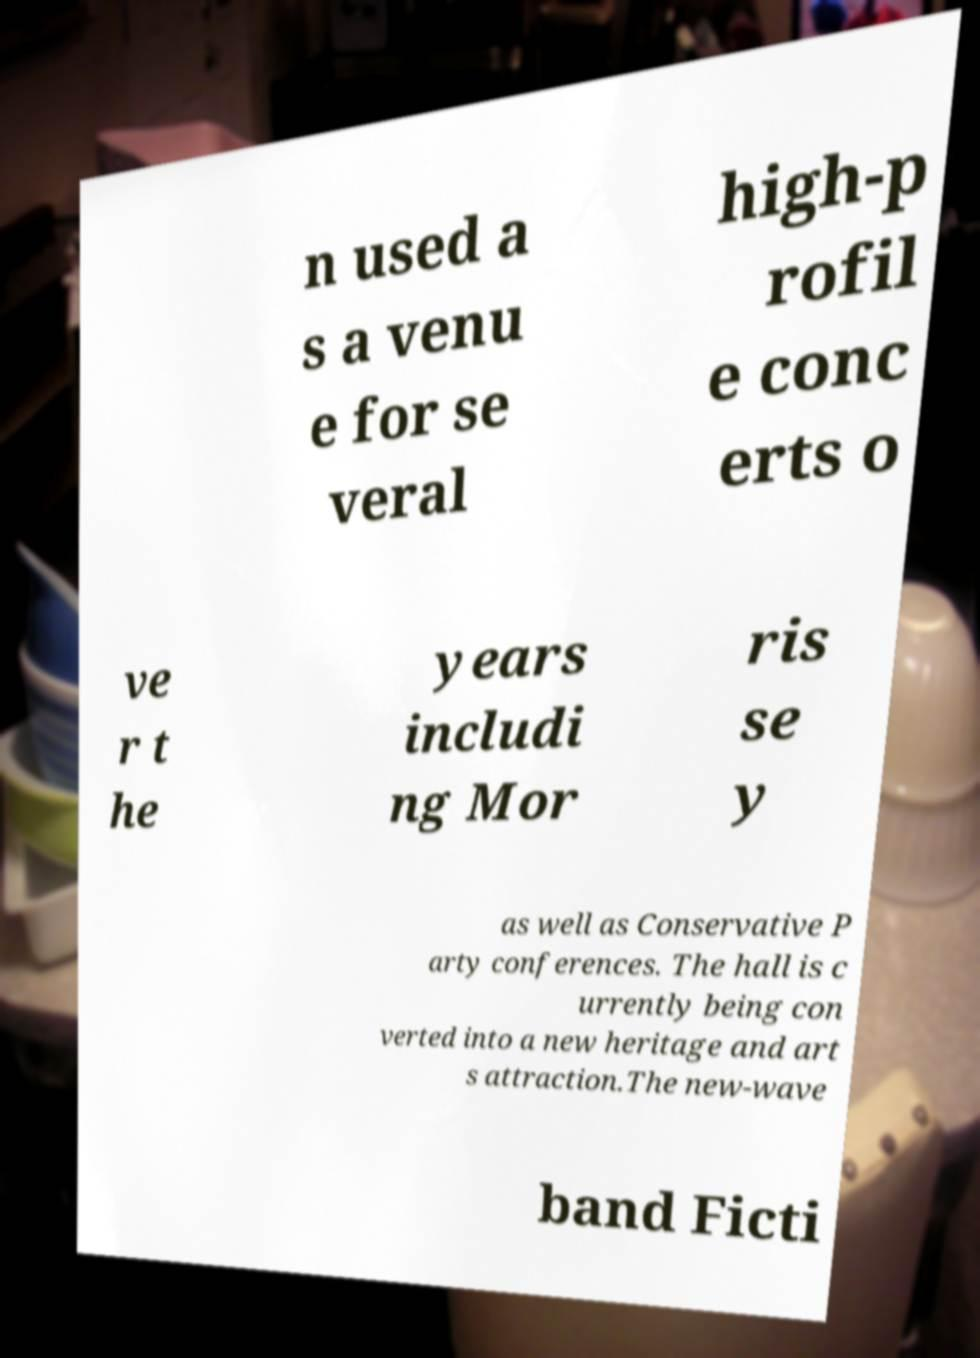What messages or text are displayed in this image? I need them in a readable, typed format. n used a s a venu e for se veral high-p rofil e conc erts o ve r t he years includi ng Mor ris se y as well as Conservative P arty conferences. The hall is c urrently being con verted into a new heritage and art s attraction.The new-wave band Ficti 